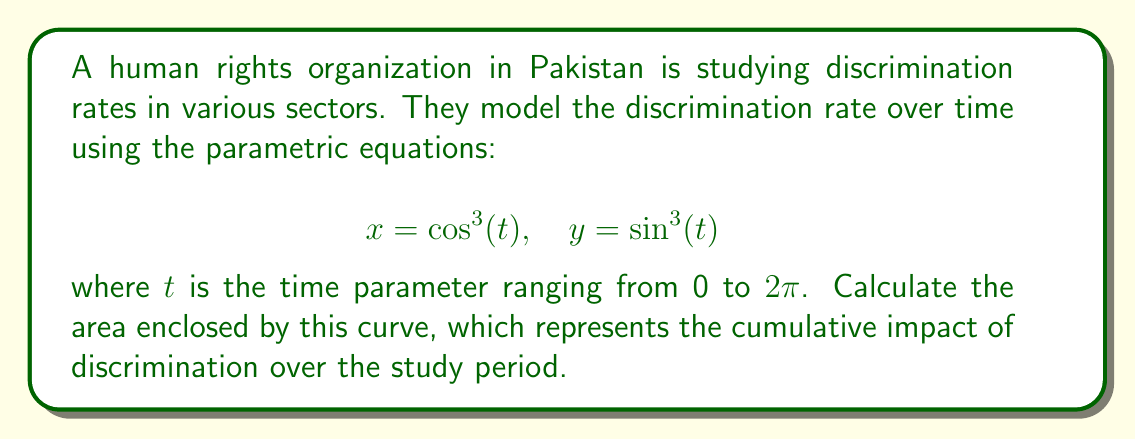Can you answer this question? To calculate the area enclosed by a parametric curve, we can use the formula:

$$\text{Area} = \frac{1}{2} \int_{0}^{2\pi} [x(t)\frac{dy}{dt} - y(t)\frac{dx}{dt}] dt$$

Let's follow these steps:

1) First, we need to find $\frac{dx}{dt}$ and $\frac{dy}{dt}$:

   $$\frac{dx}{dt} = -3\cos^2(t)\sin(t)$$
   $$\frac{dy}{dt} = 3\sin^2(t)\cos(t)$$

2) Now, let's substitute these into our area formula:

   $$\text{Area} = \frac{1}{2} \int_{0}^{2\pi} [\cos^3(t)(3\sin^2(t)\cos(t)) - \sin^3(t)(-3\cos^2(t)\sin(t))] dt$$

3) Simplify:

   $$\text{Area} = \frac{1}{2} \int_{0}^{2\pi} [3\cos^4(t)\sin^2(t) + 3\cos^2(t)\sin^4(t)] dt$$
   $$= \frac{3}{2} \int_{0}^{2\pi} [\cos^4(t)\sin^2(t) + \cos^2(t)\sin^4(t)] dt$$

4) Use the identity $\cos^2(t) + \sin^2(t) = 1$:

   $$= \frac{3}{2} \int_{0}^{2\pi} [\cos^2(t)\sin^2(t)(\cos^2(t) + \sin^2(t))] dt$$
   $$= \frac{3}{2} \int_{0}^{2\pi} \cos^2(t)\sin^2(t) dt$$

5) Use the half-angle formula $\cos^2(t)\sin^2(t) = \frac{1}{16}[1-\cos(4t)]$:

   $$= \frac{3}{2} \int_{0}^{2\pi} \frac{1}{16}[1-\cos(4t)] dt$$
   $$= \frac{3}{32} \int_{0}^{2\pi} [1-\cos(4t)] dt$$

6) Integrate:

   $$= \frac{3}{32} [t - \frac{1}{4}\sin(4t)]_{0}^{2\pi}$$
   $$= \frac{3}{32} [2\pi - 0 - (0 - 0)]$$
   $$= \frac{3\pi}{16}$$

Therefore, the area enclosed by the curve is $\frac{3\pi}{16}$.
Answer: $\frac{3\pi}{16}$ square units 